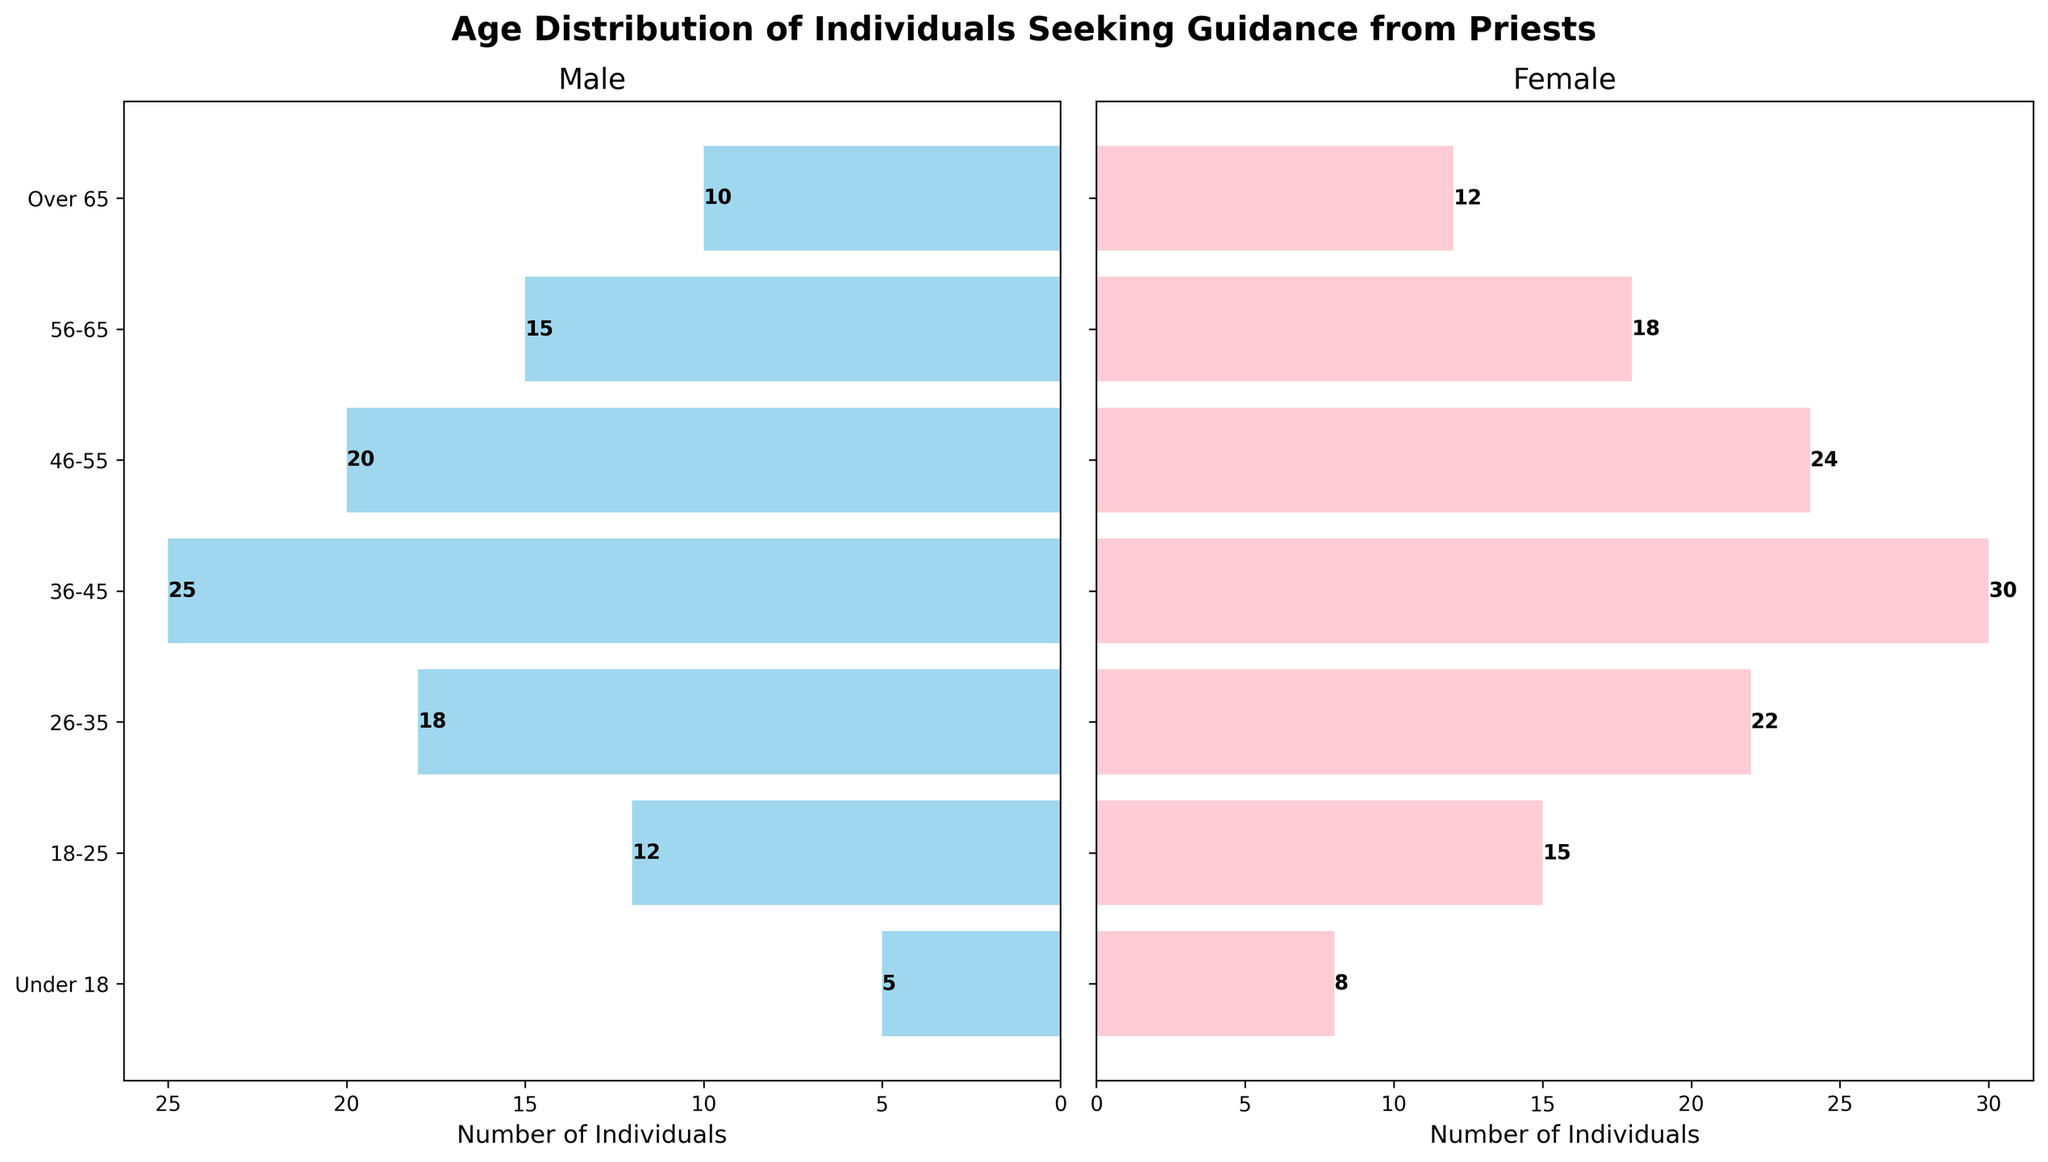What is the title of the figure? The title is located at the top center of the figure. It reads: "Age Distribution of Individuals Seeking Guidance from Priests".
Answer: Age Distribution of Individuals Seeking Guidance from Priests Which subplot represents females? The figure has two subplots; the female subplot is the one on the right-hand side.
Answer: The right subplot How many males are there in the 36-45 age group? Look at the male subplot on the left, specifically at the bar corresponding to the age group 36-45, the number beside the bar is 25.
Answer: 25 What is the total number of individuals under 18 years old? Add the number of males (5) and females (8) in the Under 18 age group. 5 + 8 equals 13.
Answer: 13 In which age group do females surpass males most significantly? Compare the difference between females and males in all age groups. The largest difference is for the 36-45 age group with females (30) and males (25), a difference of 30 - 25 = 5.
Answer: 36-45 What is the average number of individuals in the 26-35 age group for both genders? Add the number of males (18) and females (22) in the 26-35 age group and divide by 2. (18 + 22) / 2 = 20.
Answer: 20 Which gender has a higher number of individuals over 65 years old? Compare the values in the Over 65 age group for males (10) and females (12). Females have a higher number (12).
Answer: Females What is the sum of individuals in the 18-25 and 56-65 age groups combined for both genders? Add the numbers for males and females in the 18-25 (12 + 15) and 56-65 (15 + 18) age groups. Total is (12 + 15) + (15 + 18) = 60.
Answer: 60 Which age group has the least number of individuals seeking guidance when combining both genders? Sum the numbers for males and females in each age group and find the smallest total. The Under 18 group has a total of 13, the lowest combined number.
Answer: Under 18 How many individuals in total are in the 46-55 age group? Add the number of males (20) and females (24) in the 46-55 age group. Total is 20 + 24 = 44.
Answer: 44 